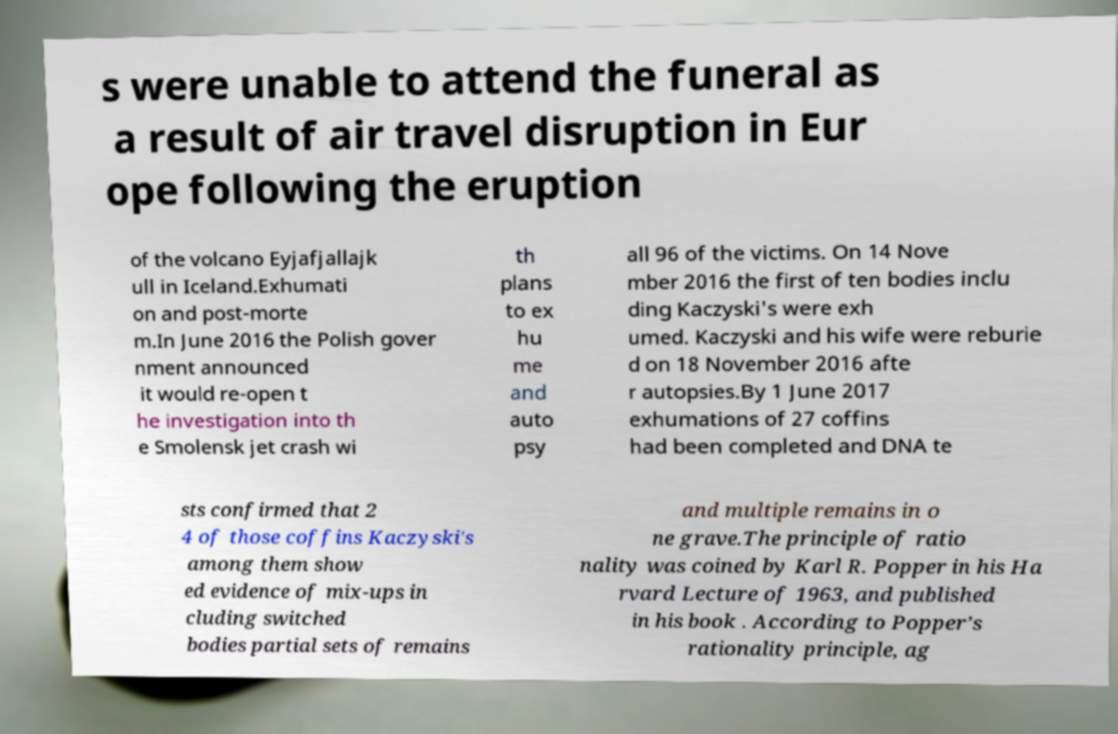For documentation purposes, I need the text within this image transcribed. Could you provide that? s were unable to attend the funeral as a result of air travel disruption in Eur ope following the eruption of the volcano Eyjafjallajk ull in Iceland.Exhumati on and post-morte m.In June 2016 the Polish gover nment announced it would re-open t he investigation into th e Smolensk jet crash wi th plans to ex hu me and auto psy all 96 of the victims. On 14 Nove mber 2016 the first of ten bodies inclu ding Kaczyski's were exh umed. Kaczyski and his wife were reburie d on 18 November 2016 afte r autopsies.By 1 June 2017 exhumations of 27 coffins had been completed and DNA te sts confirmed that 2 4 of those coffins Kaczyski's among them show ed evidence of mix-ups in cluding switched bodies partial sets of remains and multiple remains in o ne grave.The principle of ratio nality was coined by Karl R. Popper in his Ha rvard Lecture of 1963, and published in his book . According to Popper’s rationality principle, ag 